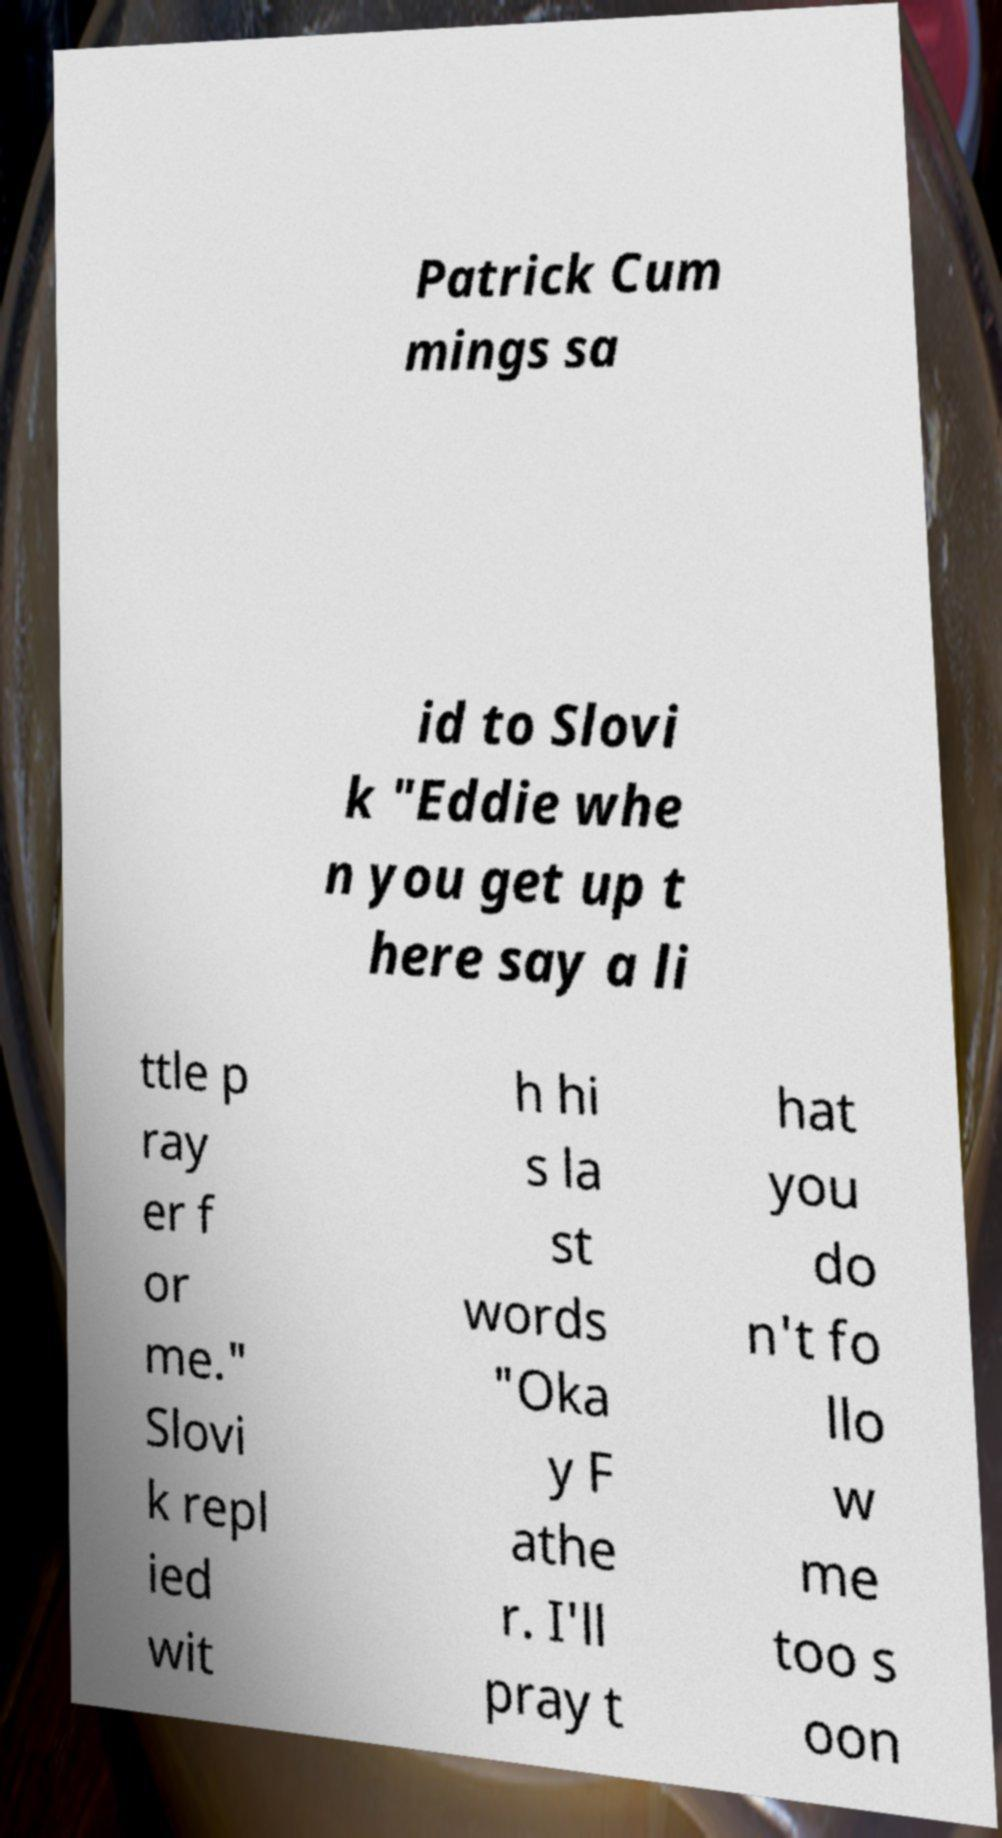Could you extract and type out the text from this image? Patrick Cum mings sa id to Slovi k "Eddie whe n you get up t here say a li ttle p ray er f or me." Slovi k repl ied wit h hi s la st words "Oka y F athe r. I'll pray t hat you do n't fo llo w me too s oon 